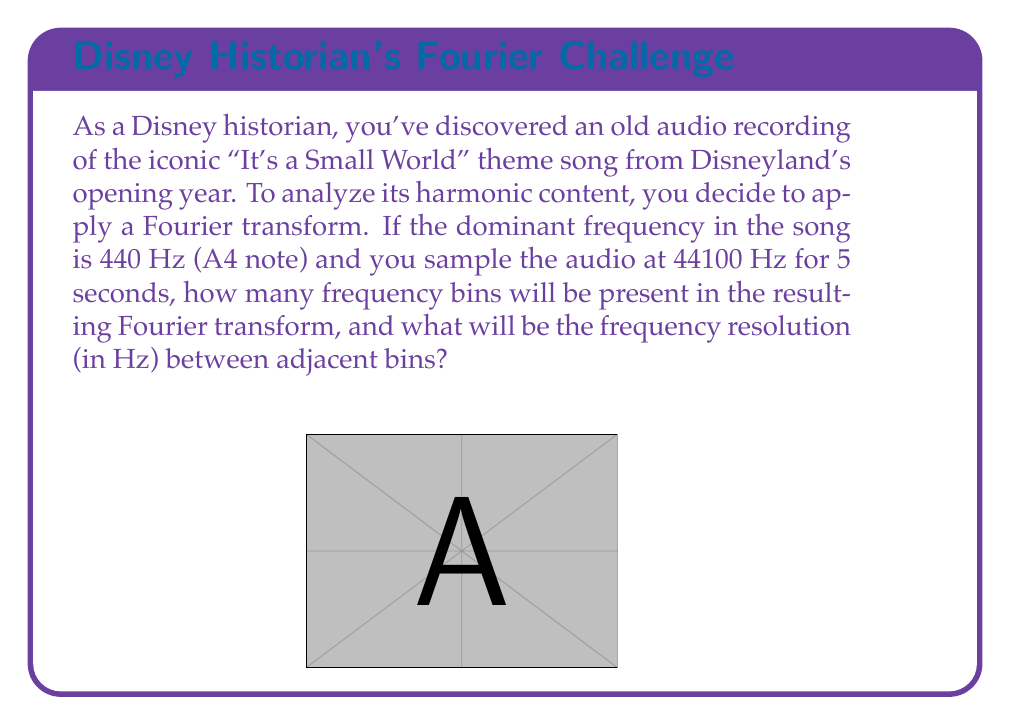Can you answer this question? Let's approach this step-by-step:

1) First, we need to understand what the Fourier transform does. It converts a time-domain signal into a frequency-domain representation.

2) The number of frequency bins in a Discrete Fourier Transform (DFT) is equal to the number of time-domain samples. So we need to calculate the number of samples:

   Sampling rate = 44100 Hz
   Duration = 5 seconds
   Number of samples = $44100 \times 5 = 220500$

3) Therefore, the number of frequency bins will be 220500.

4) The frequency resolution is the range of frequencies covered by each bin. It's calculated as:

   $$\text{Frequency Resolution} = \frac{\text{Sampling Rate}}{\text{Number of Samples}}$$

5) Plugging in our values:

   $$\text{Frequency Resolution} = \frac{44100}{220500} = 0.2 \text{ Hz}$$

This means each frequency bin represents a 0.2 Hz range of frequencies.
Answer: 220500 bins; 0.2 Hz resolution 